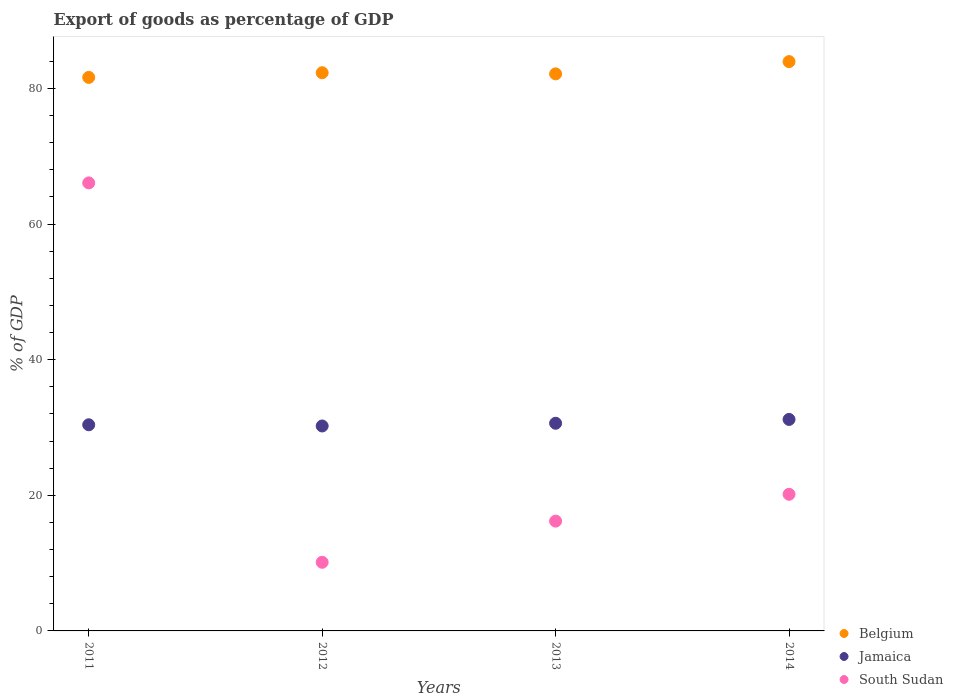How many different coloured dotlines are there?
Give a very brief answer. 3. Is the number of dotlines equal to the number of legend labels?
Provide a succinct answer. Yes. What is the export of goods as percentage of GDP in Jamaica in 2012?
Your answer should be very brief. 30.23. Across all years, what is the maximum export of goods as percentage of GDP in Belgium?
Ensure brevity in your answer.  83.96. Across all years, what is the minimum export of goods as percentage of GDP in South Sudan?
Your response must be concise. 10.12. What is the total export of goods as percentage of GDP in Belgium in the graph?
Offer a terse response. 330.08. What is the difference between the export of goods as percentage of GDP in Belgium in 2011 and that in 2013?
Keep it short and to the point. -0.52. What is the difference between the export of goods as percentage of GDP in Belgium in 2011 and the export of goods as percentage of GDP in South Sudan in 2012?
Ensure brevity in your answer.  71.51. What is the average export of goods as percentage of GDP in Jamaica per year?
Offer a very short reply. 30.61. In the year 2013, what is the difference between the export of goods as percentage of GDP in South Sudan and export of goods as percentage of GDP in Belgium?
Offer a very short reply. -65.96. In how many years, is the export of goods as percentage of GDP in South Sudan greater than 36 %?
Ensure brevity in your answer.  1. What is the ratio of the export of goods as percentage of GDP in South Sudan in 2012 to that in 2014?
Offer a very short reply. 0.5. What is the difference between the highest and the second highest export of goods as percentage of GDP in Belgium?
Your answer should be compact. 1.64. What is the difference between the highest and the lowest export of goods as percentage of GDP in South Sudan?
Your response must be concise. 55.95. In how many years, is the export of goods as percentage of GDP in Belgium greater than the average export of goods as percentage of GDP in Belgium taken over all years?
Offer a very short reply. 1. Does the export of goods as percentage of GDP in South Sudan monotonically increase over the years?
Make the answer very short. No. Is the export of goods as percentage of GDP in South Sudan strictly greater than the export of goods as percentage of GDP in Belgium over the years?
Make the answer very short. No. Is the export of goods as percentage of GDP in Belgium strictly less than the export of goods as percentage of GDP in South Sudan over the years?
Your answer should be compact. No. How many years are there in the graph?
Provide a short and direct response. 4. Does the graph contain any zero values?
Your answer should be very brief. No. What is the title of the graph?
Ensure brevity in your answer.  Export of goods as percentage of GDP. Does "Timor-Leste" appear as one of the legend labels in the graph?
Provide a short and direct response. No. What is the label or title of the X-axis?
Your answer should be compact. Years. What is the label or title of the Y-axis?
Ensure brevity in your answer.  % of GDP. What is the % of GDP of Belgium in 2011?
Ensure brevity in your answer.  81.64. What is the % of GDP of Jamaica in 2011?
Offer a terse response. 30.4. What is the % of GDP in South Sudan in 2011?
Give a very brief answer. 66.08. What is the % of GDP of Belgium in 2012?
Offer a terse response. 82.32. What is the % of GDP in Jamaica in 2012?
Your answer should be compact. 30.23. What is the % of GDP of South Sudan in 2012?
Make the answer very short. 10.12. What is the % of GDP of Belgium in 2013?
Keep it short and to the point. 82.16. What is the % of GDP of Jamaica in 2013?
Offer a very short reply. 30.63. What is the % of GDP of South Sudan in 2013?
Offer a terse response. 16.2. What is the % of GDP of Belgium in 2014?
Your answer should be very brief. 83.96. What is the % of GDP in Jamaica in 2014?
Your answer should be compact. 31.19. What is the % of GDP in South Sudan in 2014?
Your response must be concise. 20.15. Across all years, what is the maximum % of GDP in Belgium?
Your answer should be compact. 83.96. Across all years, what is the maximum % of GDP in Jamaica?
Offer a very short reply. 31.19. Across all years, what is the maximum % of GDP of South Sudan?
Provide a short and direct response. 66.08. Across all years, what is the minimum % of GDP of Belgium?
Make the answer very short. 81.64. Across all years, what is the minimum % of GDP in Jamaica?
Your answer should be very brief. 30.23. Across all years, what is the minimum % of GDP in South Sudan?
Keep it short and to the point. 10.12. What is the total % of GDP in Belgium in the graph?
Your answer should be compact. 330.08. What is the total % of GDP in Jamaica in the graph?
Provide a succinct answer. 122.45. What is the total % of GDP of South Sudan in the graph?
Provide a short and direct response. 112.54. What is the difference between the % of GDP in Belgium in 2011 and that in 2012?
Give a very brief answer. -0.69. What is the difference between the % of GDP of Jamaica in 2011 and that in 2012?
Provide a short and direct response. 0.18. What is the difference between the % of GDP of South Sudan in 2011 and that in 2012?
Offer a terse response. 55.95. What is the difference between the % of GDP in Belgium in 2011 and that in 2013?
Keep it short and to the point. -0.52. What is the difference between the % of GDP of Jamaica in 2011 and that in 2013?
Offer a very short reply. -0.22. What is the difference between the % of GDP of South Sudan in 2011 and that in 2013?
Ensure brevity in your answer.  49.88. What is the difference between the % of GDP of Belgium in 2011 and that in 2014?
Your answer should be very brief. -2.33. What is the difference between the % of GDP in Jamaica in 2011 and that in 2014?
Make the answer very short. -0.79. What is the difference between the % of GDP of South Sudan in 2011 and that in 2014?
Make the answer very short. 45.92. What is the difference between the % of GDP in Belgium in 2012 and that in 2013?
Your answer should be compact. 0.17. What is the difference between the % of GDP of Jamaica in 2012 and that in 2013?
Keep it short and to the point. -0.4. What is the difference between the % of GDP of South Sudan in 2012 and that in 2013?
Your response must be concise. -6.07. What is the difference between the % of GDP in Belgium in 2012 and that in 2014?
Provide a short and direct response. -1.64. What is the difference between the % of GDP of Jamaica in 2012 and that in 2014?
Keep it short and to the point. -0.97. What is the difference between the % of GDP of South Sudan in 2012 and that in 2014?
Make the answer very short. -10.03. What is the difference between the % of GDP of Belgium in 2013 and that in 2014?
Your response must be concise. -1.81. What is the difference between the % of GDP in Jamaica in 2013 and that in 2014?
Give a very brief answer. -0.56. What is the difference between the % of GDP of South Sudan in 2013 and that in 2014?
Provide a short and direct response. -3.96. What is the difference between the % of GDP of Belgium in 2011 and the % of GDP of Jamaica in 2012?
Your answer should be very brief. 51.41. What is the difference between the % of GDP in Belgium in 2011 and the % of GDP in South Sudan in 2012?
Make the answer very short. 71.51. What is the difference between the % of GDP of Jamaica in 2011 and the % of GDP of South Sudan in 2012?
Ensure brevity in your answer.  20.28. What is the difference between the % of GDP of Belgium in 2011 and the % of GDP of Jamaica in 2013?
Offer a very short reply. 51.01. What is the difference between the % of GDP of Belgium in 2011 and the % of GDP of South Sudan in 2013?
Keep it short and to the point. 65.44. What is the difference between the % of GDP of Jamaica in 2011 and the % of GDP of South Sudan in 2013?
Ensure brevity in your answer.  14.21. What is the difference between the % of GDP in Belgium in 2011 and the % of GDP in Jamaica in 2014?
Offer a very short reply. 50.44. What is the difference between the % of GDP of Belgium in 2011 and the % of GDP of South Sudan in 2014?
Make the answer very short. 61.48. What is the difference between the % of GDP of Jamaica in 2011 and the % of GDP of South Sudan in 2014?
Your response must be concise. 10.25. What is the difference between the % of GDP in Belgium in 2012 and the % of GDP in Jamaica in 2013?
Make the answer very short. 51.7. What is the difference between the % of GDP of Belgium in 2012 and the % of GDP of South Sudan in 2013?
Provide a short and direct response. 66.13. What is the difference between the % of GDP in Jamaica in 2012 and the % of GDP in South Sudan in 2013?
Your answer should be very brief. 14.03. What is the difference between the % of GDP in Belgium in 2012 and the % of GDP in Jamaica in 2014?
Your answer should be very brief. 51.13. What is the difference between the % of GDP in Belgium in 2012 and the % of GDP in South Sudan in 2014?
Offer a very short reply. 62.17. What is the difference between the % of GDP in Jamaica in 2012 and the % of GDP in South Sudan in 2014?
Your answer should be compact. 10.07. What is the difference between the % of GDP of Belgium in 2013 and the % of GDP of Jamaica in 2014?
Your answer should be very brief. 50.96. What is the difference between the % of GDP of Belgium in 2013 and the % of GDP of South Sudan in 2014?
Provide a succinct answer. 62.01. What is the difference between the % of GDP in Jamaica in 2013 and the % of GDP in South Sudan in 2014?
Your answer should be very brief. 10.48. What is the average % of GDP in Belgium per year?
Offer a very short reply. 82.52. What is the average % of GDP in Jamaica per year?
Provide a succinct answer. 30.61. What is the average % of GDP in South Sudan per year?
Ensure brevity in your answer.  28.14. In the year 2011, what is the difference between the % of GDP of Belgium and % of GDP of Jamaica?
Ensure brevity in your answer.  51.23. In the year 2011, what is the difference between the % of GDP of Belgium and % of GDP of South Sudan?
Offer a very short reply. 15.56. In the year 2011, what is the difference between the % of GDP in Jamaica and % of GDP in South Sudan?
Offer a terse response. -35.67. In the year 2012, what is the difference between the % of GDP in Belgium and % of GDP in Jamaica?
Ensure brevity in your answer.  52.1. In the year 2012, what is the difference between the % of GDP in Belgium and % of GDP in South Sudan?
Provide a succinct answer. 72.2. In the year 2012, what is the difference between the % of GDP in Jamaica and % of GDP in South Sudan?
Make the answer very short. 20.1. In the year 2013, what is the difference between the % of GDP in Belgium and % of GDP in Jamaica?
Make the answer very short. 51.53. In the year 2013, what is the difference between the % of GDP of Belgium and % of GDP of South Sudan?
Make the answer very short. 65.96. In the year 2013, what is the difference between the % of GDP of Jamaica and % of GDP of South Sudan?
Make the answer very short. 14.43. In the year 2014, what is the difference between the % of GDP of Belgium and % of GDP of Jamaica?
Your answer should be compact. 52.77. In the year 2014, what is the difference between the % of GDP in Belgium and % of GDP in South Sudan?
Make the answer very short. 63.81. In the year 2014, what is the difference between the % of GDP of Jamaica and % of GDP of South Sudan?
Provide a succinct answer. 11.04. What is the ratio of the % of GDP in Jamaica in 2011 to that in 2012?
Offer a very short reply. 1.01. What is the ratio of the % of GDP of South Sudan in 2011 to that in 2012?
Provide a short and direct response. 6.53. What is the ratio of the % of GDP in Belgium in 2011 to that in 2013?
Offer a terse response. 0.99. What is the ratio of the % of GDP of Jamaica in 2011 to that in 2013?
Your answer should be compact. 0.99. What is the ratio of the % of GDP in South Sudan in 2011 to that in 2013?
Provide a succinct answer. 4.08. What is the ratio of the % of GDP of Belgium in 2011 to that in 2014?
Your response must be concise. 0.97. What is the ratio of the % of GDP of Jamaica in 2011 to that in 2014?
Provide a short and direct response. 0.97. What is the ratio of the % of GDP in South Sudan in 2011 to that in 2014?
Your answer should be compact. 3.28. What is the ratio of the % of GDP of Belgium in 2012 to that in 2013?
Make the answer very short. 1. What is the ratio of the % of GDP of Jamaica in 2012 to that in 2013?
Provide a short and direct response. 0.99. What is the ratio of the % of GDP in South Sudan in 2012 to that in 2013?
Provide a short and direct response. 0.62. What is the ratio of the % of GDP in Belgium in 2012 to that in 2014?
Offer a terse response. 0.98. What is the ratio of the % of GDP in South Sudan in 2012 to that in 2014?
Your answer should be very brief. 0.5. What is the ratio of the % of GDP in Belgium in 2013 to that in 2014?
Offer a terse response. 0.98. What is the ratio of the % of GDP of Jamaica in 2013 to that in 2014?
Your response must be concise. 0.98. What is the ratio of the % of GDP in South Sudan in 2013 to that in 2014?
Keep it short and to the point. 0.8. What is the difference between the highest and the second highest % of GDP of Belgium?
Provide a short and direct response. 1.64. What is the difference between the highest and the second highest % of GDP in Jamaica?
Offer a terse response. 0.56. What is the difference between the highest and the second highest % of GDP of South Sudan?
Offer a very short reply. 45.92. What is the difference between the highest and the lowest % of GDP in Belgium?
Give a very brief answer. 2.33. What is the difference between the highest and the lowest % of GDP in South Sudan?
Provide a succinct answer. 55.95. 